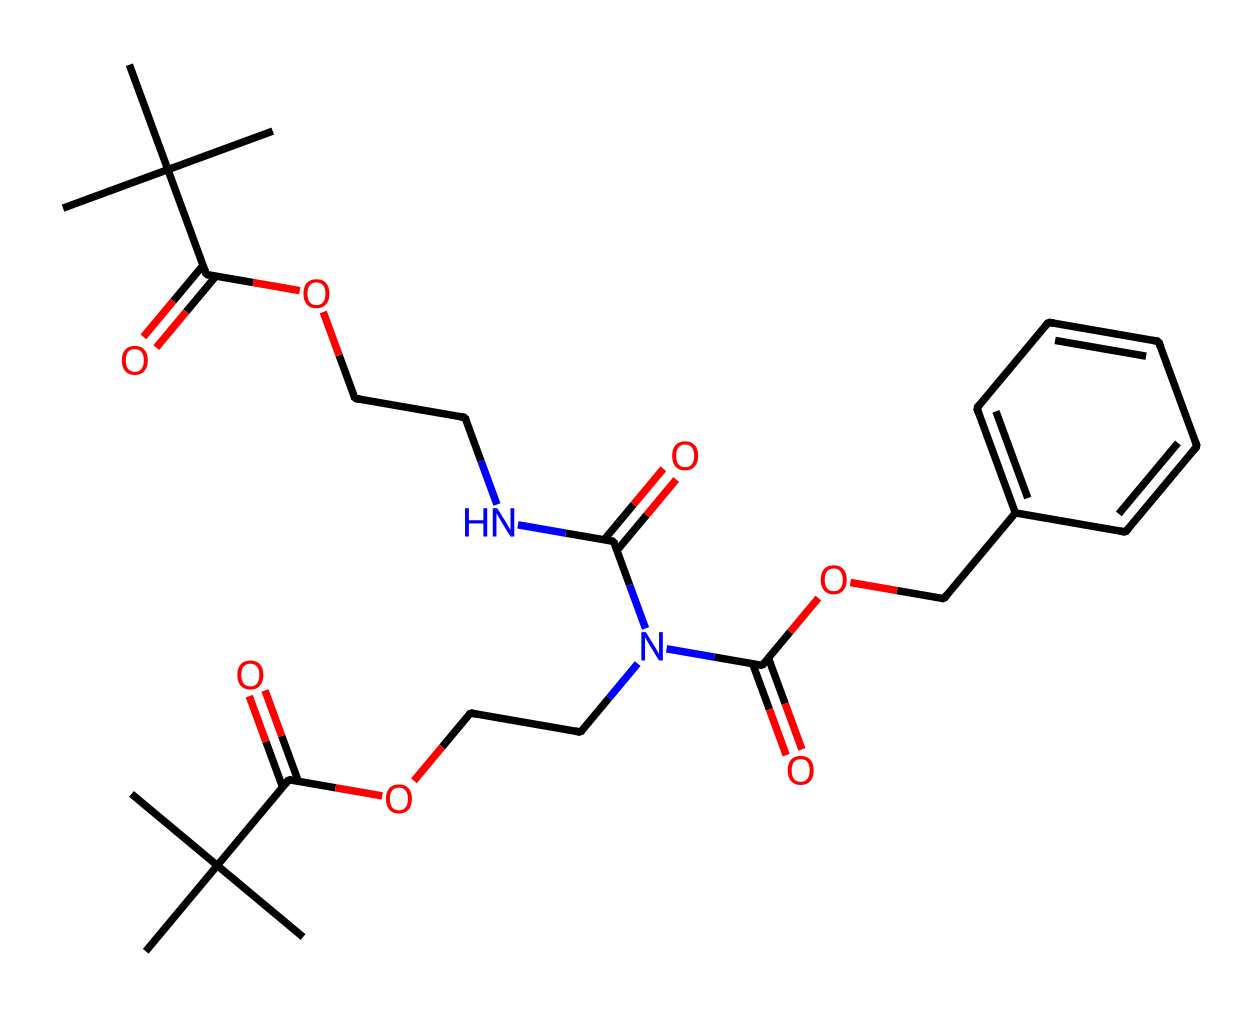What is the functional group present in the molecule? The molecule contains a carboxylic acid functional group, indicated by the -COOH structure towards the beginning of the SMILES representation and multiple carbonyl (C=O) features.
Answer: carboxylic acid How many carbon atoms are present in the chemical structure? By analyzing the SMILES representation, you can count there are 18 carbon atoms (C) visually represented by distinct carbon connections and branching.
Answer: 18 What type of polymer does this molecule represent? The structure includes urethane linkages (indicated by the presence of -N-C(=O)-O-) suggesting it is a polyurethane-based polymer, typical for varnish applications.
Answer: polyurethane How many nitrogen atoms are in the composition? The SMILES representation shows two distinct nitrogen atoms (N) mainly indicated by the N in the structure surrounded by carbon and oxygen atoms, confirming their presence.
Answer: 2 What is the total number of ester linkages in this molecule? Reviewing the connections in the SMILES, there are two instances of -O-C(=O)- (ester groups), confirming the presence of two ester linkages critical for the properties of varnish.
Answer: 2 What impact does the bulky isopropyl groups have on the varnish? The bulky isopropyl (C) groups hinder closer packing of polymer chains, resulting in enhanced flexibility and impact resistance of the varnish, a characteristic explored in varnish formulations.
Answer: flexibility 